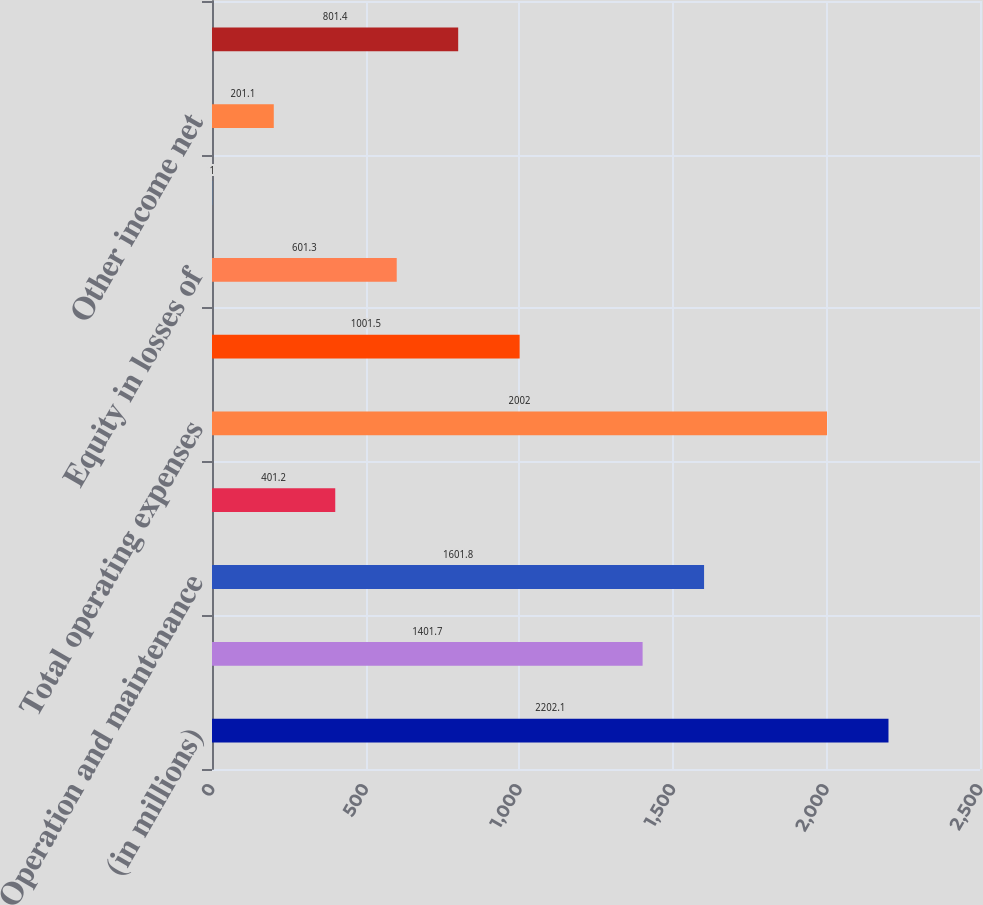<chart> <loc_0><loc_0><loc_500><loc_500><bar_chart><fcel>(in millions)<fcel>Operating revenues<fcel>Operation and maintenance<fcel>Depreciation and amortization<fcel>Total operating expenses<fcel>Operating income<fcel>Equity in losses of<fcel>Leveraged lease income<fcel>Other income net<fcel>Interest expenses<nl><fcel>2202.1<fcel>1401.7<fcel>1601.8<fcel>401.2<fcel>2002<fcel>1001.5<fcel>601.3<fcel>1<fcel>201.1<fcel>801.4<nl></chart> 